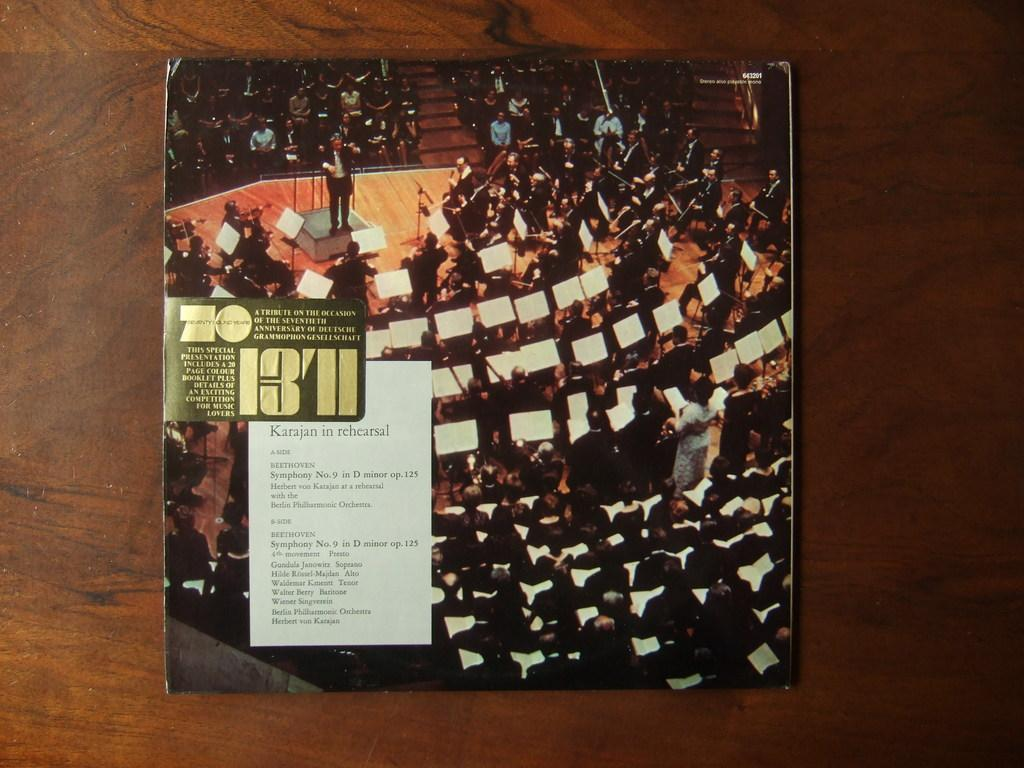<image>
Write a terse but informative summary of the picture. The label on the album indicates it's a tribute to the 70th anniversary of the Deutsch Grammophon Gesselschaft. 